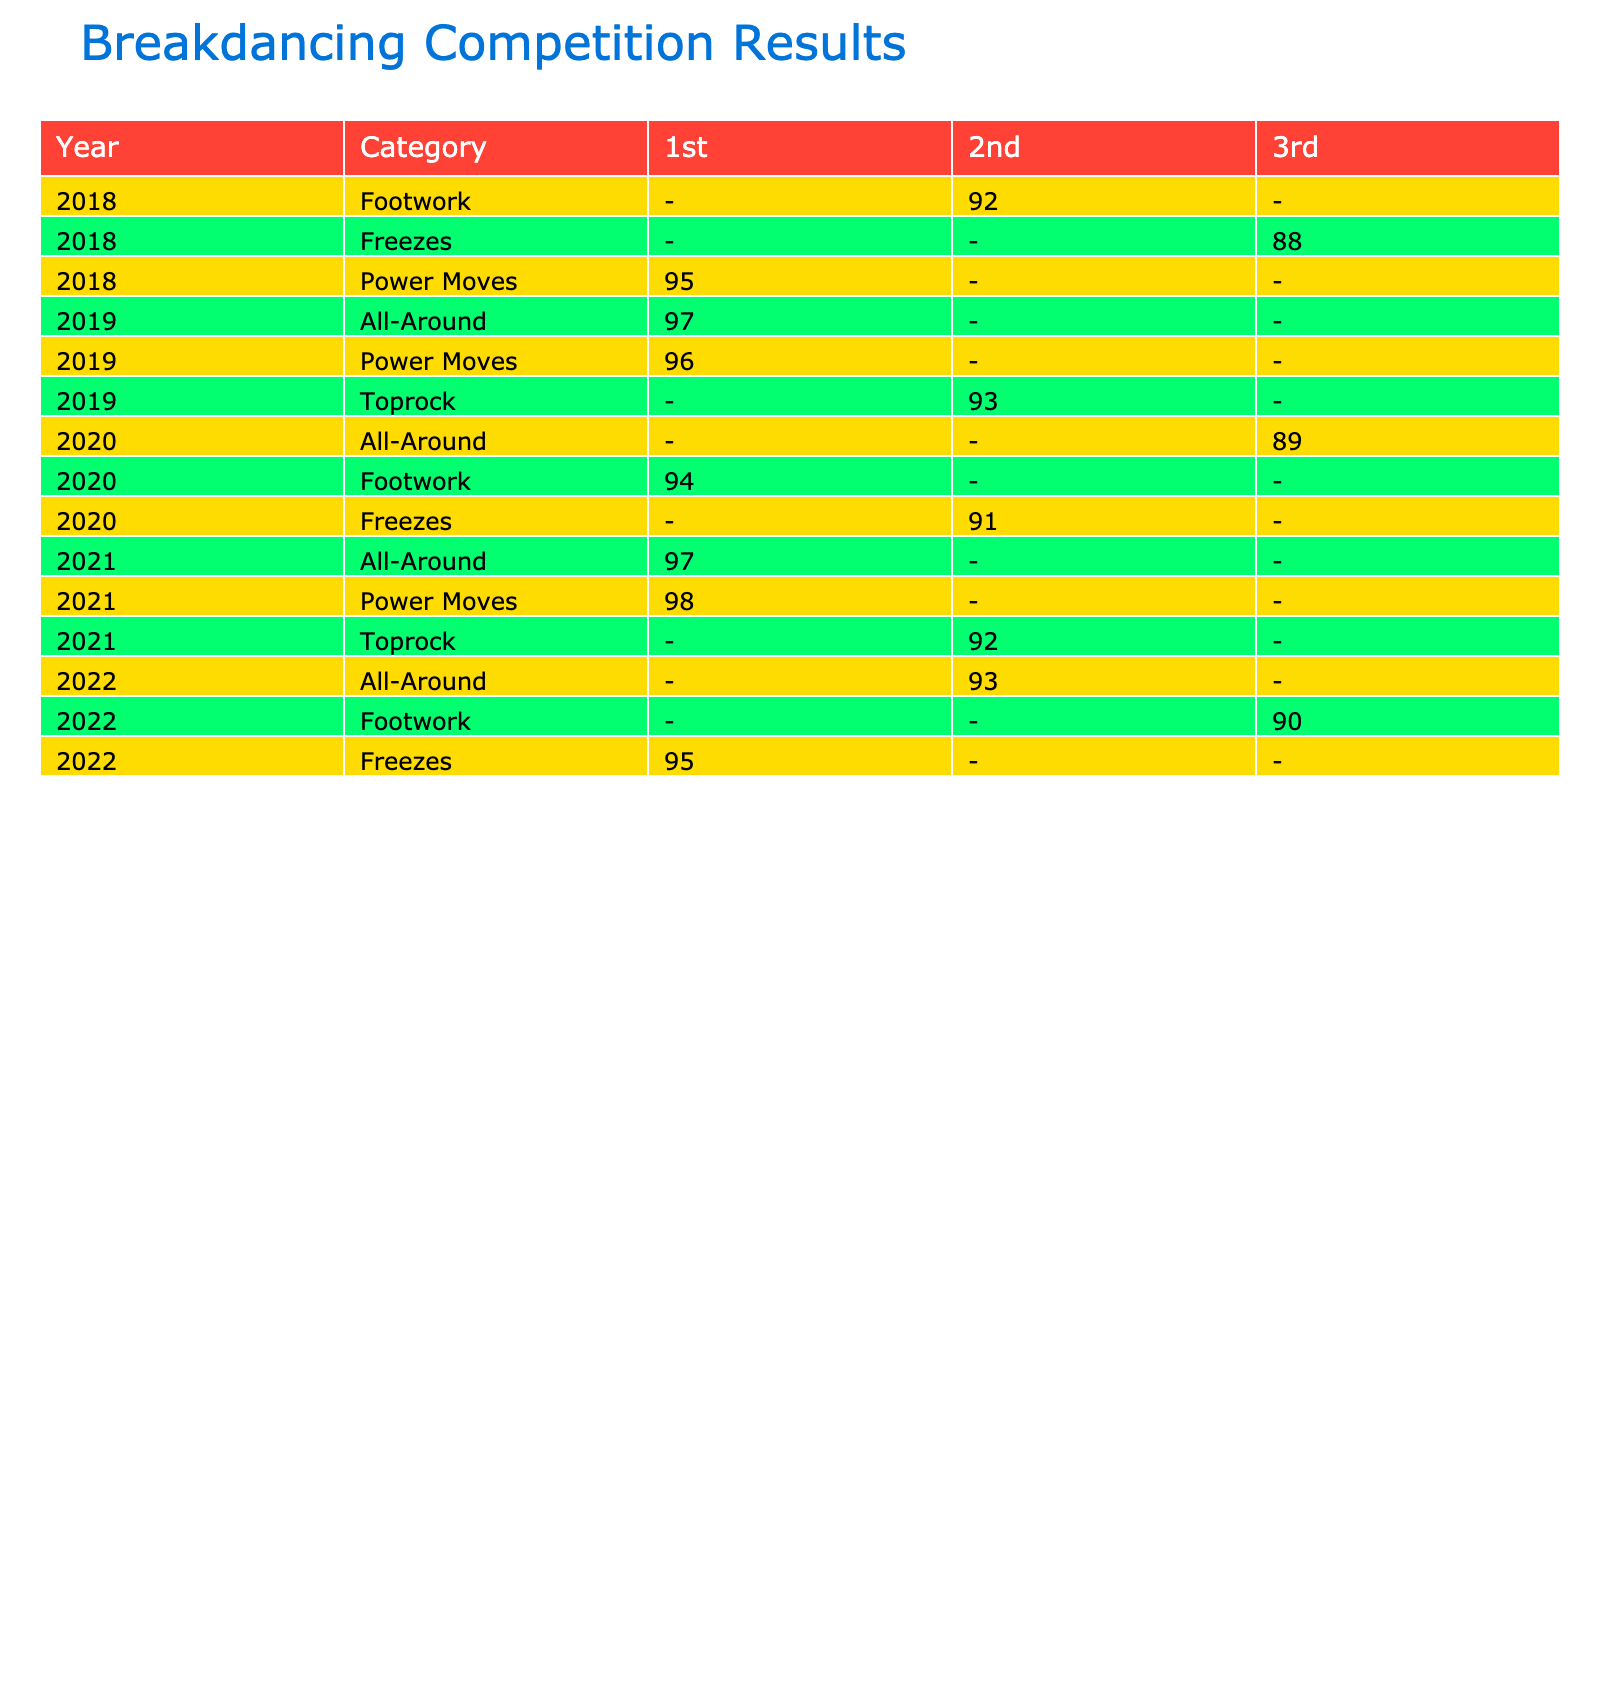What was the top score for Power Moves in 2018? In 2018, the only recorded score in the Power Moves category is by B-Boy Gravity, who placed 1st with a score of 95. Therefore, the top score is 95.
Answer: 95 Which year had the most competitions for All-Around dancers? The All-Around category has entries in 2019, 2021, and 2022. In 2019, there was 1 All-Around entry; in 2021, there were 2 entries; and in 2022, there was 1 entry. Therefore, 2021 had the most competitions for All-Around dancers with a total of 2.
Answer: 2021 Did B-Girl Kastet ever place 3rd in a competition? Looking at the table, B-Girl Kastet is listed for the Footwork category in 2020 and placed 1st. There are no entries showing that she placed 3rd in any competition. Hence, the answer is no.
Answer: No What is the average score for 1st place in 2021? In 2021, the scores for those who placed 1st are B-Boy Phil Wizard with 98 and B-Girl Logistx with 97. To find the average, we sum these scores: 98 + 97 = 195. Then divide by the number of entries: 195 / 2 = 97.5. Therefore, the average score for 1st place in 2021 is 97.5.
Answer: 97.5 How many dancers placed in the top 2 across all categories in 2019? In 2019, there were two dancers that placed in the top 2: B-Boy Menno (1st) and B-Girl Ami (2nd). Therefore, the total number of dancers who placed in the top 2 in 2019 is 2.
Answer: 2 